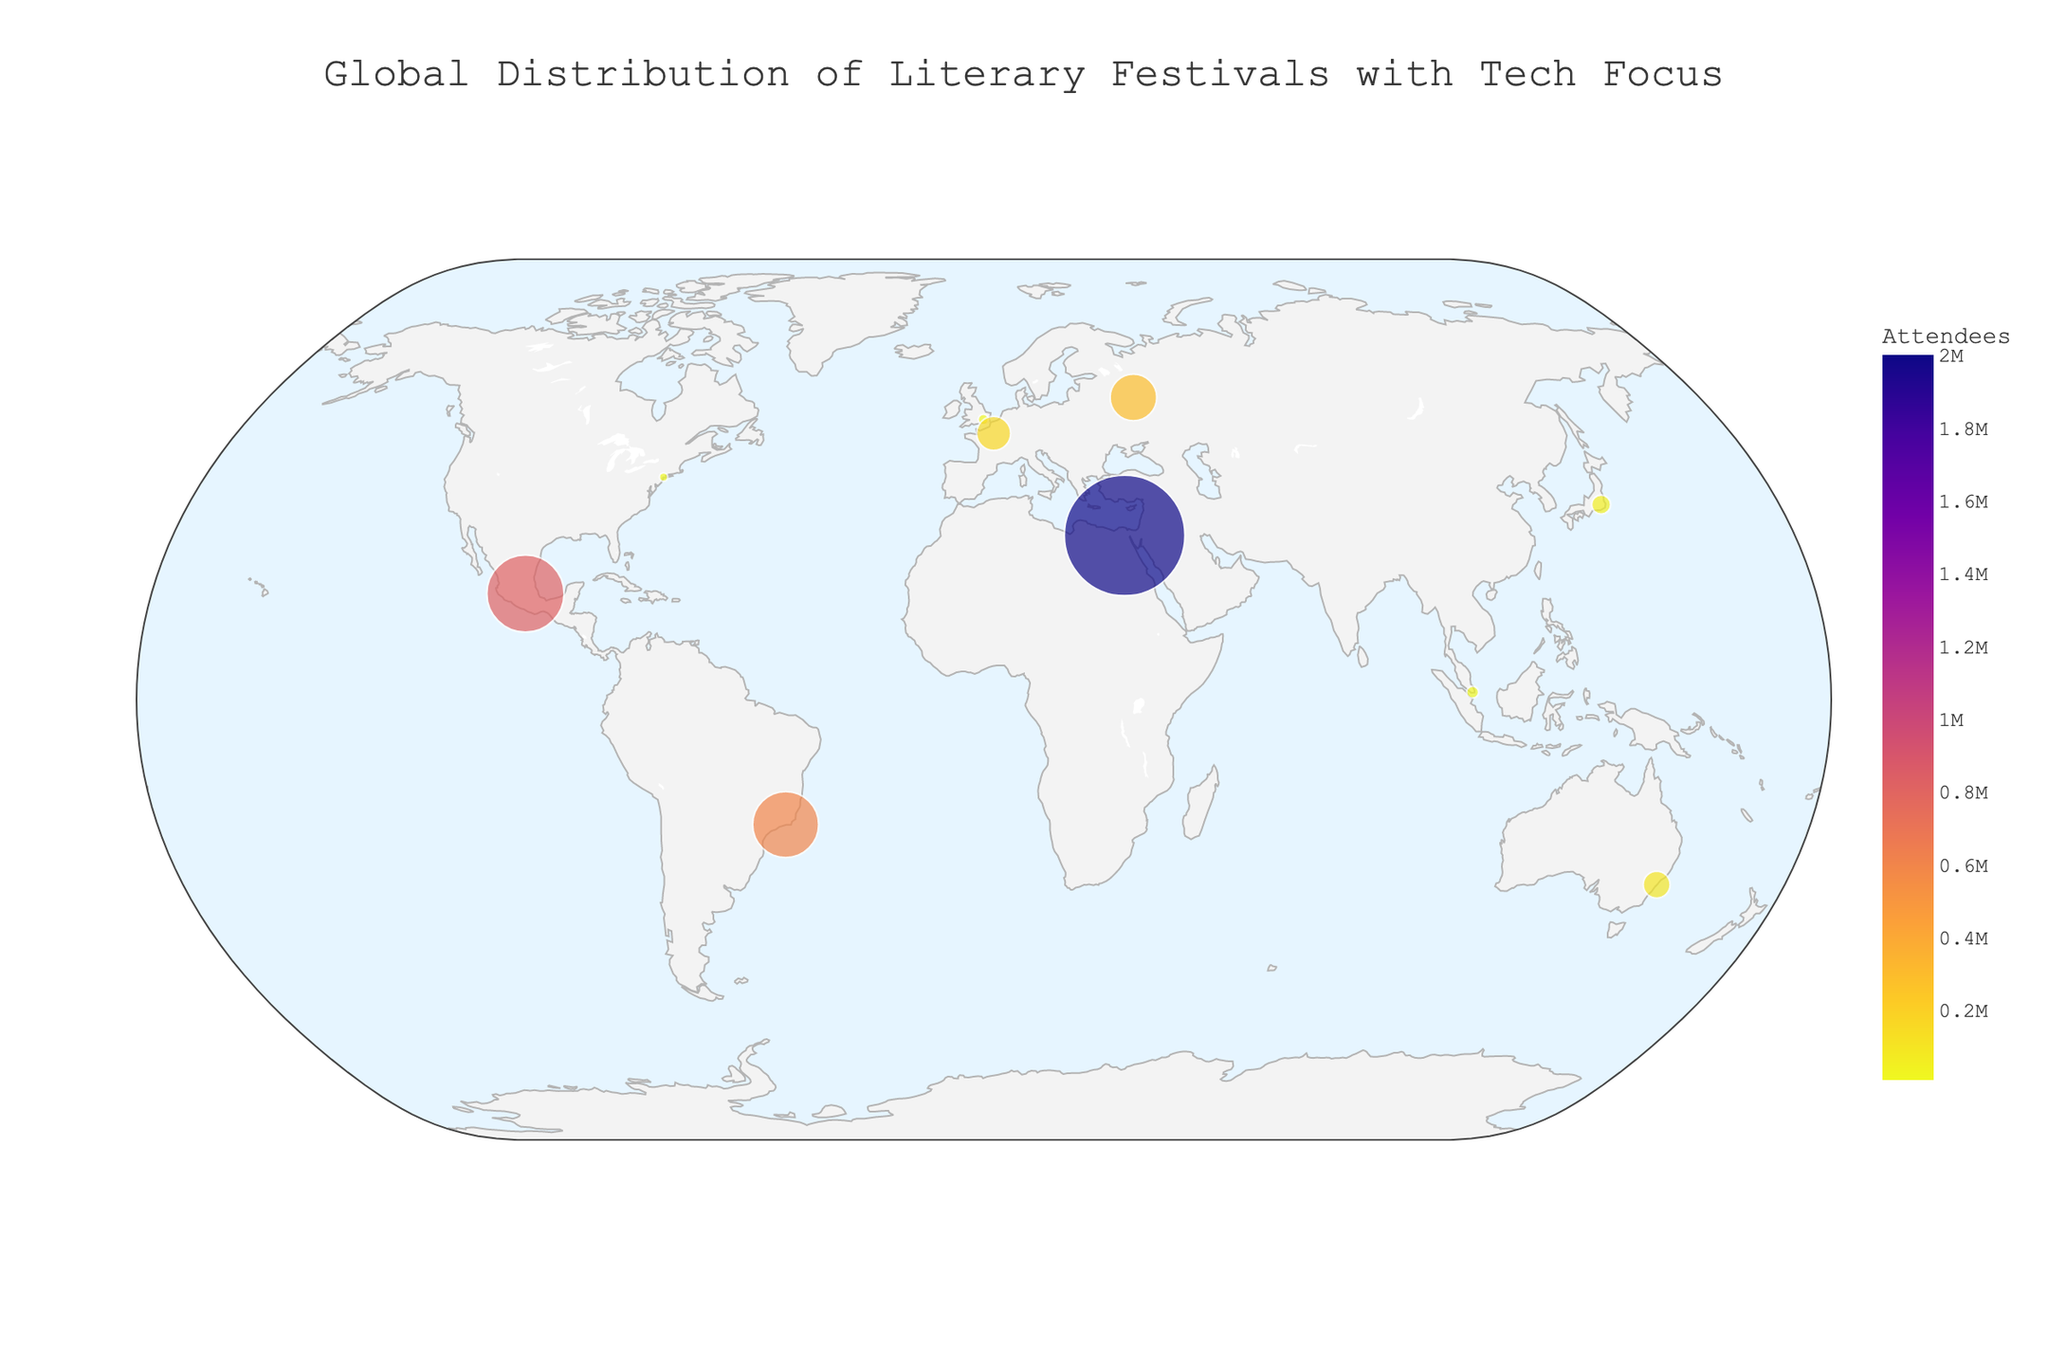How many literary festivals are depicted in the figure? Count the number of unique festival names displayed on the map.
Answer: 10 Which festival has the highest number of attendees? Look for the festival with the largest marker size and check its annotation for attendee details.
Answer: Cairo International Book Fair What is the total number of attendees for the festivals in North America? Identify the festivals in North America (PEN World Voices Festival in New York, USA), and sum their attendees.
Answer: 10,000 Which festival has a focus on 'AI in Fiction'? Check the hover data on the plot for 'Tech Focus' and find the one labeled 'AI in Fiction'.
Answer: PEN World Voices Festival What is the average number of attendees for festivals in Asia? Identify the festivals in Asia (Tokyo International Literary Festival and Singapore Writers Festival), sum their attendees and divide by the number of festivals (50,000 + 20,000) / 2.
Answer: 35,000 Which festival in Europe has the fewest attendees? Identify European festivals from the plot, then compare their attendees: London Literature Festival (15,000) and Paris Book Fair (160,000).
Answer: London Literature Festival What is the combined number of attendees for festivals in Europe? Identify the festivals in Europe (London Literature Festival and Paris Book Fair) and sum their attendees.
Answer: 175,000 What is the technology focus of the festival with the second-highest number of attendees? Identify the festival with the second-largest marker size using attendee numbers (600,000) and check its tech focus.
Answer: Eco-tech Storytelling 